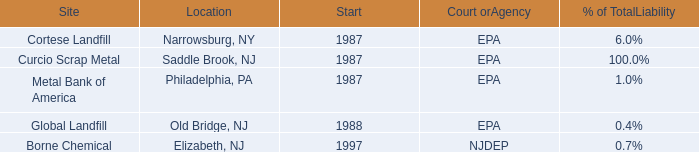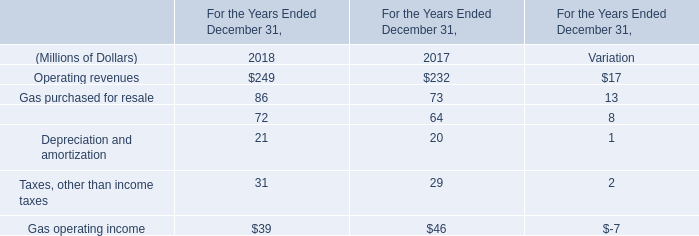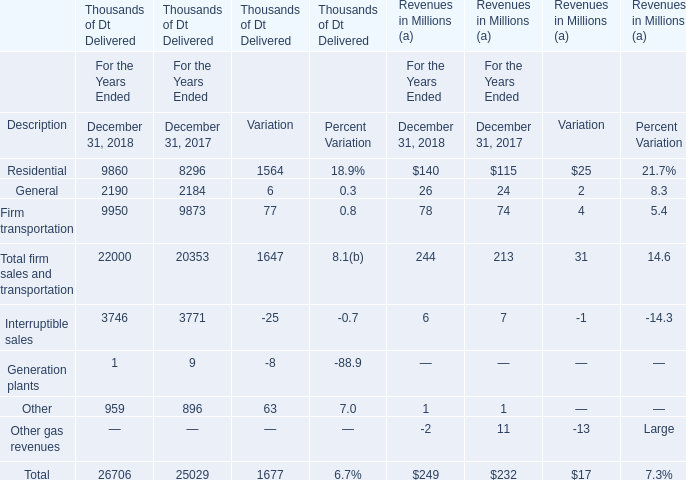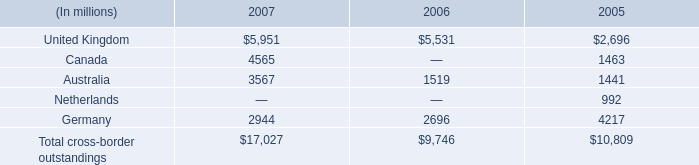In which year does the total value of gas operating income ranks first? 
Answer: 2017. 